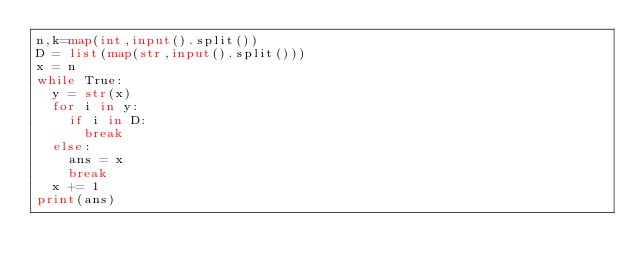Convert code to text. <code><loc_0><loc_0><loc_500><loc_500><_Python_>n,k=map(int,input().split())
D = list(map(str,input().split()))
x = n
while True:
  y = str(x)
  for i in y:
    if i in D:
      break
  else:
    ans = x
    break
  x += 1
print(ans)</code> 